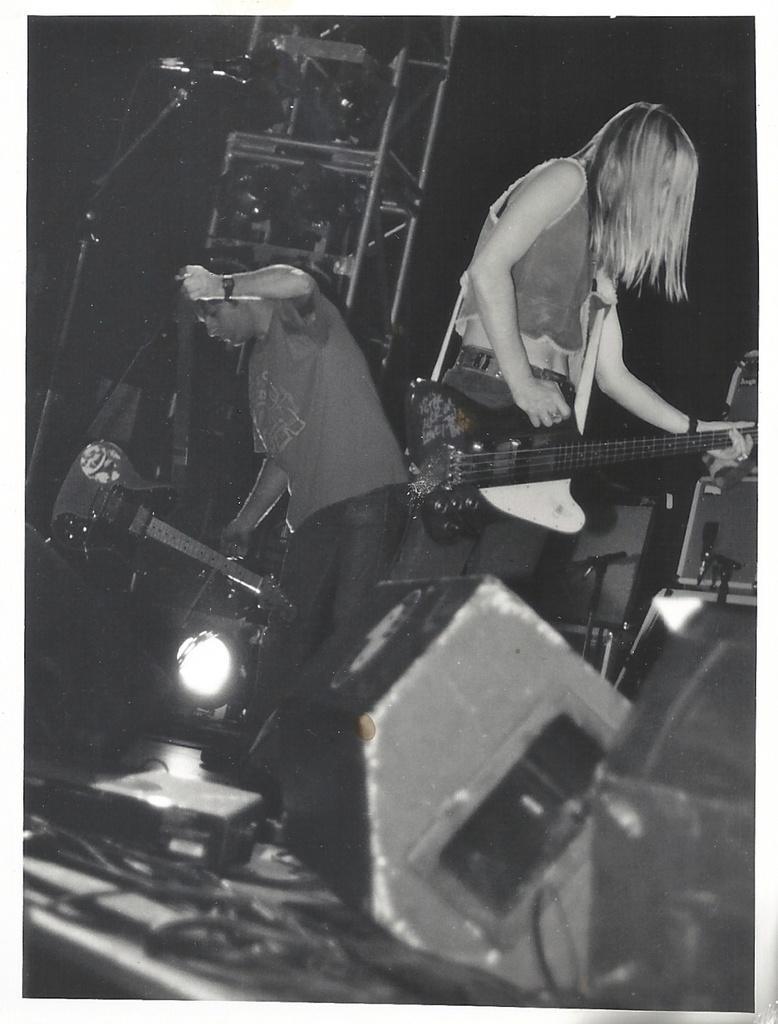Please provide a concise description of this image. There is a woman standing on the right side. She is holding a guitar in her hand. There is a man standing on the left side. 